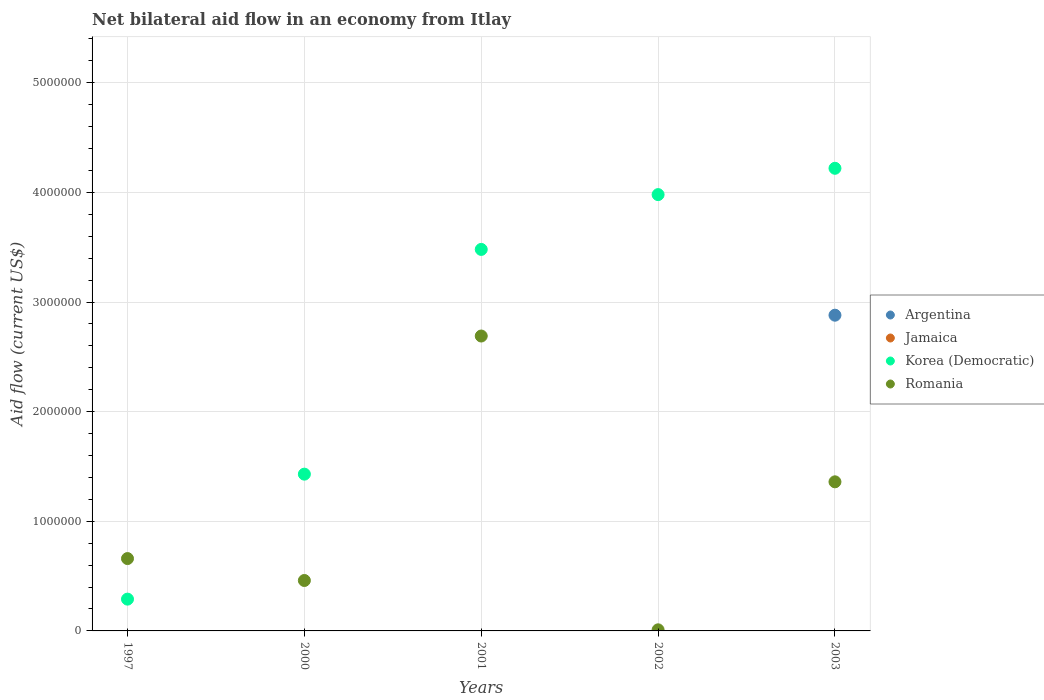What is the net bilateral aid flow in Korea (Democratic) in 2001?
Your answer should be compact. 3.48e+06. Across all years, what is the maximum net bilateral aid flow in Argentina?
Your answer should be very brief. 2.88e+06. Across all years, what is the minimum net bilateral aid flow in Romania?
Make the answer very short. 10000. What is the total net bilateral aid flow in Romania in the graph?
Offer a terse response. 5.18e+06. What is the difference between the net bilateral aid flow in Romania in 2001 and that in 2002?
Offer a terse response. 2.68e+06. What is the difference between the net bilateral aid flow in Romania in 2002 and the net bilateral aid flow in Korea (Democratic) in 2001?
Offer a very short reply. -3.47e+06. In how many years, is the net bilateral aid flow in Romania greater than 2200000 US$?
Give a very brief answer. 1. What is the ratio of the net bilateral aid flow in Korea (Democratic) in 2000 to that in 2001?
Make the answer very short. 0.41. What is the difference between the highest and the second highest net bilateral aid flow in Romania?
Provide a succinct answer. 1.33e+06. What is the difference between the highest and the lowest net bilateral aid flow in Korea (Democratic)?
Provide a short and direct response. 3.93e+06. In how many years, is the net bilateral aid flow in Romania greater than the average net bilateral aid flow in Romania taken over all years?
Give a very brief answer. 2. Is it the case that in every year, the sum of the net bilateral aid flow in Korea (Democratic) and net bilateral aid flow in Romania  is greater than the sum of net bilateral aid flow in Jamaica and net bilateral aid flow in Argentina?
Give a very brief answer. Yes. Is the net bilateral aid flow in Jamaica strictly greater than the net bilateral aid flow in Argentina over the years?
Give a very brief answer. No. How many years are there in the graph?
Offer a very short reply. 5. What is the difference between two consecutive major ticks on the Y-axis?
Offer a terse response. 1.00e+06. What is the title of the graph?
Offer a very short reply. Net bilateral aid flow in an economy from Itlay. Does "Guyana" appear as one of the legend labels in the graph?
Your answer should be very brief. No. What is the label or title of the X-axis?
Ensure brevity in your answer.  Years. What is the Aid flow (current US$) in Argentina in 1997?
Your response must be concise. 0. What is the Aid flow (current US$) in Jamaica in 1997?
Keep it short and to the point. 0. What is the Aid flow (current US$) in Korea (Democratic) in 1997?
Your answer should be very brief. 2.90e+05. What is the Aid flow (current US$) in Jamaica in 2000?
Provide a succinct answer. 0. What is the Aid flow (current US$) in Korea (Democratic) in 2000?
Give a very brief answer. 1.43e+06. What is the Aid flow (current US$) in Korea (Democratic) in 2001?
Provide a succinct answer. 3.48e+06. What is the Aid flow (current US$) of Romania in 2001?
Make the answer very short. 2.69e+06. What is the Aid flow (current US$) of Jamaica in 2002?
Your answer should be compact. 0. What is the Aid flow (current US$) of Korea (Democratic) in 2002?
Your answer should be very brief. 3.98e+06. What is the Aid flow (current US$) of Romania in 2002?
Your answer should be compact. 10000. What is the Aid flow (current US$) of Argentina in 2003?
Keep it short and to the point. 2.88e+06. What is the Aid flow (current US$) of Jamaica in 2003?
Provide a short and direct response. 0. What is the Aid flow (current US$) in Korea (Democratic) in 2003?
Offer a very short reply. 4.22e+06. What is the Aid flow (current US$) in Romania in 2003?
Provide a short and direct response. 1.36e+06. Across all years, what is the maximum Aid flow (current US$) in Argentina?
Offer a very short reply. 2.88e+06. Across all years, what is the maximum Aid flow (current US$) in Korea (Democratic)?
Make the answer very short. 4.22e+06. Across all years, what is the maximum Aid flow (current US$) in Romania?
Ensure brevity in your answer.  2.69e+06. What is the total Aid flow (current US$) of Argentina in the graph?
Make the answer very short. 2.88e+06. What is the total Aid flow (current US$) in Jamaica in the graph?
Give a very brief answer. 0. What is the total Aid flow (current US$) of Korea (Democratic) in the graph?
Provide a succinct answer. 1.34e+07. What is the total Aid flow (current US$) in Romania in the graph?
Ensure brevity in your answer.  5.18e+06. What is the difference between the Aid flow (current US$) in Korea (Democratic) in 1997 and that in 2000?
Make the answer very short. -1.14e+06. What is the difference between the Aid flow (current US$) of Korea (Democratic) in 1997 and that in 2001?
Provide a succinct answer. -3.19e+06. What is the difference between the Aid flow (current US$) in Romania in 1997 and that in 2001?
Provide a succinct answer. -2.03e+06. What is the difference between the Aid flow (current US$) of Korea (Democratic) in 1997 and that in 2002?
Ensure brevity in your answer.  -3.69e+06. What is the difference between the Aid flow (current US$) in Romania in 1997 and that in 2002?
Keep it short and to the point. 6.50e+05. What is the difference between the Aid flow (current US$) of Korea (Democratic) in 1997 and that in 2003?
Give a very brief answer. -3.93e+06. What is the difference between the Aid flow (current US$) in Romania in 1997 and that in 2003?
Keep it short and to the point. -7.00e+05. What is the difference between the Aid flow (current US$) of Korea (Democratic) in 2000 and that in 2001?
Give a very brief answer. -2.05e+06. What is the difference between the Aid flow (current US$) of Romania in 2000 and that in 2001?
Provide a succinct answer. -2.23e+06. What is the difference between the Aid flow (current US$) in Korea (Democratic) in 2000 and that in 2002?
Your answer should be very brief. -2.55e+06. What is the difference between the Aid flow (current US$) in Korea (Democratic) in 2000 and that in 2003?
Make the answer very short. -2.79e+06. What is the difference between the Aid flow (current US$) in Romania in 2000 and that in 2003?
Offer a very short reply. -9.00e+05. What is the difference between the Aid flow (current US$) of Korea (Democratic) in 2001 and that in 2002?
Offer a terse response. -5.00e+05. What is the difference between the Aid flow (current US$) in Romania in 2001 and that in 2002?
Your answer should be compact. 2.68e+06. What is the difference between the Aid flow (current US$) in Korea (Democratic) in 2001 and that in 2003?
Offer a terse response. -7.40e+05. What is the difference between the Aid flow (current US$) of Romania in 2001 and that in 2003?
Your response must be concise. 1.33e+06. What is the difference between the Aid flow (current US$) of Romania in 2002 and that in 2003?
Keep it short and to the point. -1.35e+06. What is the difference between the Aid flow (current US$) of Korea (Democratic) in 1997 and the Aid flow (current US$) of Romania in 2001?
Your response must be concise. -2.40e+06. What is the difference between the Aid flow (current US$) in Korea (Democratic) in 1997 and the Aid flow (current US$) in Romania in 2002?
Your answer should be compact. 2.80e+05. What is the difference between the Aid flow (current US$) of Korea (Democratic) in 1997 and the Aid flow (current US$) of Romania in 2003?
Your response must be concise. -1.07e+06. What is the difference between the Aid flow (current US$) of Korea (Democratic) in 2000 and the Aid flow (current US$) of Romania in 2001?
Your response must be concise. -1.26e+06. What is the difference between the Aid flow (current US$) of Korea (Democratic) in 2000 and the Aid flow (current US$) of Romania in 2002?
Offer a terse response. 1.42e+06. What is the difference between the Aid flow (current US$) of Korea (Democratic) in 2001 and the Aid flow (current US$) of Romania in 2002?
Keep it short and to the point. 3.47e+06. What is the difference between the Aid flow (current US$) in Korea (Democratic) in 2001 and the Aid flow (current US$) in Romania in 2003?
Keep it short and to the point. 2.12e+06. What is the difference between the Aid flow (current US$) of Korea (Democratic) in 2002 and the Aid flow (current US$) of Romania in 2003?
Your response must be concise. 2.62e+06. What is the average Aid flow (current US$) of Argentina per year?
Provide a succinct answer. 5.76e+05. What is the average Aid flow (current US$) in Jamaica per year?
Your response must be concise. 0. What is the average Aid flow (current US$) of Korea (Democratic) per year?
Offer a terse response. 2.68e+06. What is the average Aid flow (current US$) in Romania per year?
Make the answer very short. 1.04e+06. In the year 1997, what is the difference between the Aid flow (current US$) in Korea (Democratic) and Aid flow (current US$) in Romania?
Offer a very short reply. -3.70e+05. In the year 2000, what is the difference between the Aid flow (current US$) in Korea (Democratic) and Aid flow (current US$) in Romania?
Provide a short and direct response. 9.70e+05. In the year 2001, what is the difference between the Aid flow (current US$) in Korea (Democratic) and Aid flow (current US$) in Romania?
Give a very brief answer. 7.90e+05. In the year 2002, what is the difference between the Aid flow (current US$) in Korea (Democratic) and Aid flow (current US$) in Romania?
Keep it short and to the point. 3.97e+06. In the year 2003, what is the difference between the Aid flow (current US$) in Argentina and Aid flow (current US$) in Korea (Democratic)?
Ensure brevity in your answer.  -1.34e+06. In the year 2003, what is the difference between the Aid flow (current US$) in Argentina and Aid flow (current US$) in Romania?
Your response must be concise. 1.52e+06. In the year 2003, what is the difference between the Aid flow (current US$) of Korea (Democratic) and Aid flow (current US$) of Romania?
Offer a terse response. 2.86e+06. What is the ratio of the Aid flow (current US$) of Korea (Democratic) in 1997 to that in 2000?
Keep it short and to the point. 0.2. What is the ratio of the Aid flow (current US$) of Romania in 1997 to that in 2000?
Your answer should be very brief. 1.43. What is the ratio of the Aid flow (current US$) of Korea (Democratic) in 1997 to that in 2001?
Provide a succinct answer. 0.08. What is the ratio of the Aid flow (current US$) of Romania in 1997 to that in 2001?
Your answer should be very brief. 0.25. What is the ratio of the Aid flow (current US$) in Korea (Democratic) in 1997 to that in 2002?
Offer a terse response. 0.07. What is the ratio of the Aid flow (current US$) in Korea (Democratic) in 1997 to that in 2003?
Your answer should be very brief. 0.07. What is the ratio of the Aid flow (current US$) of Romania in 1997 to that in 2003?
Give a very brief answer. 0.49. What is the ratio of the Aid flow (current US$) of Korea (Democratic) in 2000 to that in 2001?
Your answer should be compact. 0.41. What is the ratio of the Aid flow (current US$) of Romania in 2000 to that in 2001?
Keep it short and to the point. 0.17. What is the ratio of the Aid flow (current US$) of Korea (Democratic) in 2000 to that in 2002?
Your response must be concise. 0.36. What is the ratio of the Aid flow (current US$) of Korea (Democratic) in 2000 to that in 2003?
Keep it short and to the point. 0.34. What is the ratio of the Aid flow (current US$) in Romania in 2000 to that in 2003?
Offer a terse response. 0.34. What is the ratio of the Aid flow (current US$) in Korea (Democratic) in 2001 to that in 2002?
Your answer should be very brief. 0.87. What is the ratio of the Aid flow (current US$) in Romania in 2001 to that in 2002?
Your answer should be compact. 269. What is the ratio of the Aid flow (current US$) in Korea (Democratic) in 2001 to that in 2003?
Offer a very short reply. 0.82. What is the ratio of the Aid flow (current US$) in Romania in 2001 to that in 2003?
Offer a terse response. 1.98. What is the ratio of the Aid flow (current US$) in Korea (Democratic) in 2002 to that in 2003?
Provide a succinct answer. 0.94. What is the ratio of the Aid flow (current US$) of Romania in 2002 to that in 2003?
Give a very brief answer. 0.01. What is the difference between the highest and the second highest Aid flow (current US$) of Korea (Democratic)?
Your answer should be very brief. 2.40e+05. What is the difference between the highest and the second highest Aid flow (current US$) in Romania?
Offer a terse response. 1.33e+06. What is the difference between the highest and the lowest Aid flow (current US$) of Argentina?
Your answer should be very brief. 2.88e+06. What is the difference between the highest and the lowest Aid flow (current US$) of Korea (Democratic)?
Provide a short and direct response. 3.93e+06. What is the difference between the highest and the lowest Aid flow (current US$) in Romania?
Ensure brevity in your answer.  2.68e+06. 